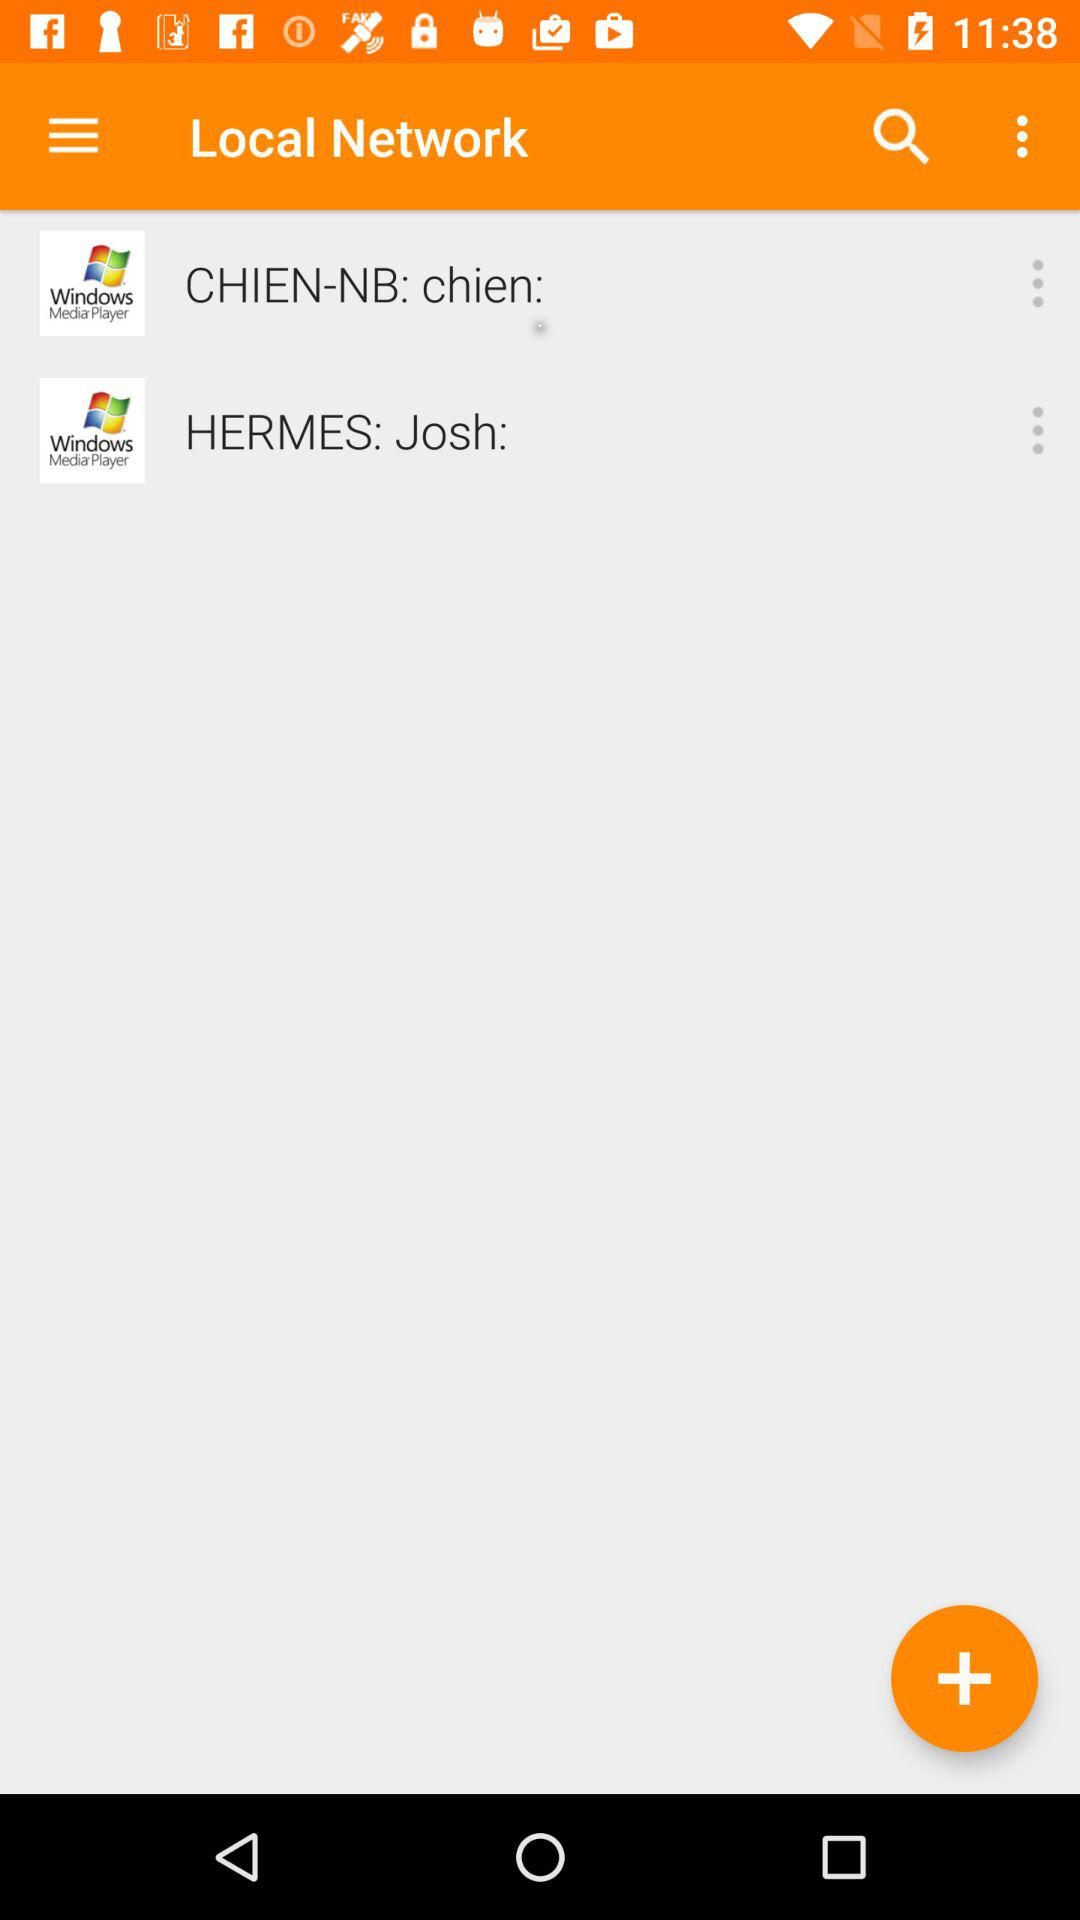What are the different "Local Network"? The different local networks are "CHIEN-NB: chien:" and "HERMES: Josh:". 